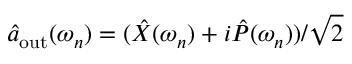<formula> <loc_0><loc_0><loc_500><loc_500>\hat { a } _ { o u t } ( \omega _ { n } ) = ( \hat { X } ( \omega _ { n } ) + i \hat { P } ( \omega _ { n } ) ) / \sqrt { 2 }</formula> 